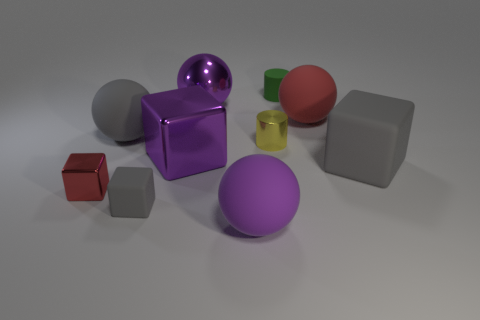How many large metal spheres are the same color as the large metallic cube?
Provide a succinct answer. 1. How many objects are tiny metallic cubes or red matte balls?
Keep it short and to the point. 2. What shape is the red matte object that is the same size as the gray ball?
Your answer should be compact. Sphere. How many large rubber spheres are on the left side of the red matte ball and behind the large purple cube?
Give a very brief answer. 1. There is a large gray object behind the small yellow thing; what is its material?
Offer a very short reply. Rubber. There is a purple sphere that is the same material as the large gray block; what is its size?
Provide a succinct answer. Large. Do the gray matte block that is right of the red rubber object and the metallic thing that is left of the large purple block have the same size?
Provide a short and direct response. No. What material is the gray cube that is the same size as the purple block?
Ensure brevity in your answer.  Rubber. There is a block that is behind the tiny red shiny cube and left of the small shiny cylinder; what is its material?
Give a very brief answer. Metal. Is there a cyan shiny sphere?
Give a very brief answer. No. 